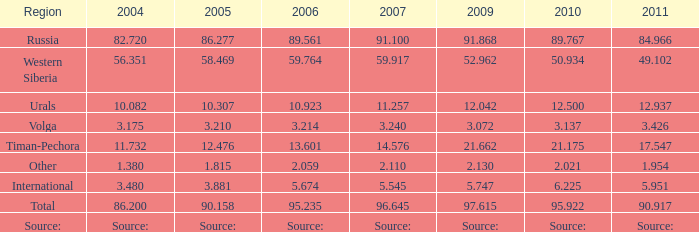Given that lukoil produced 91.100 million tonnes of oil in 2007, what was the production amount in 2005? 86.277. 